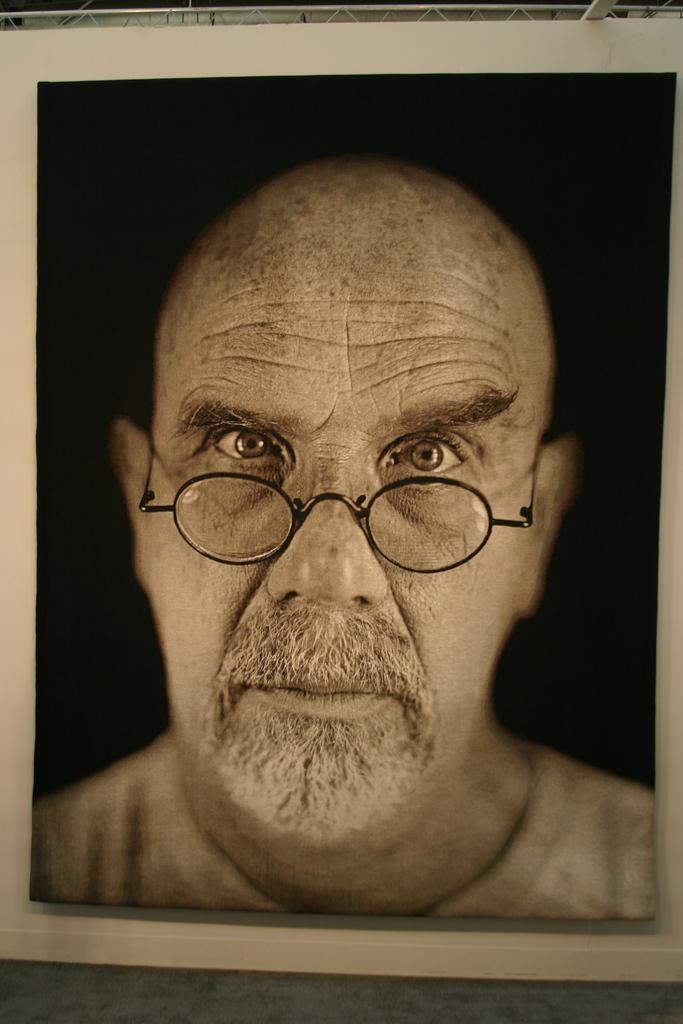Can you describe this image briefly? In this image we can see a photo frame of a person wearing spectacles. 